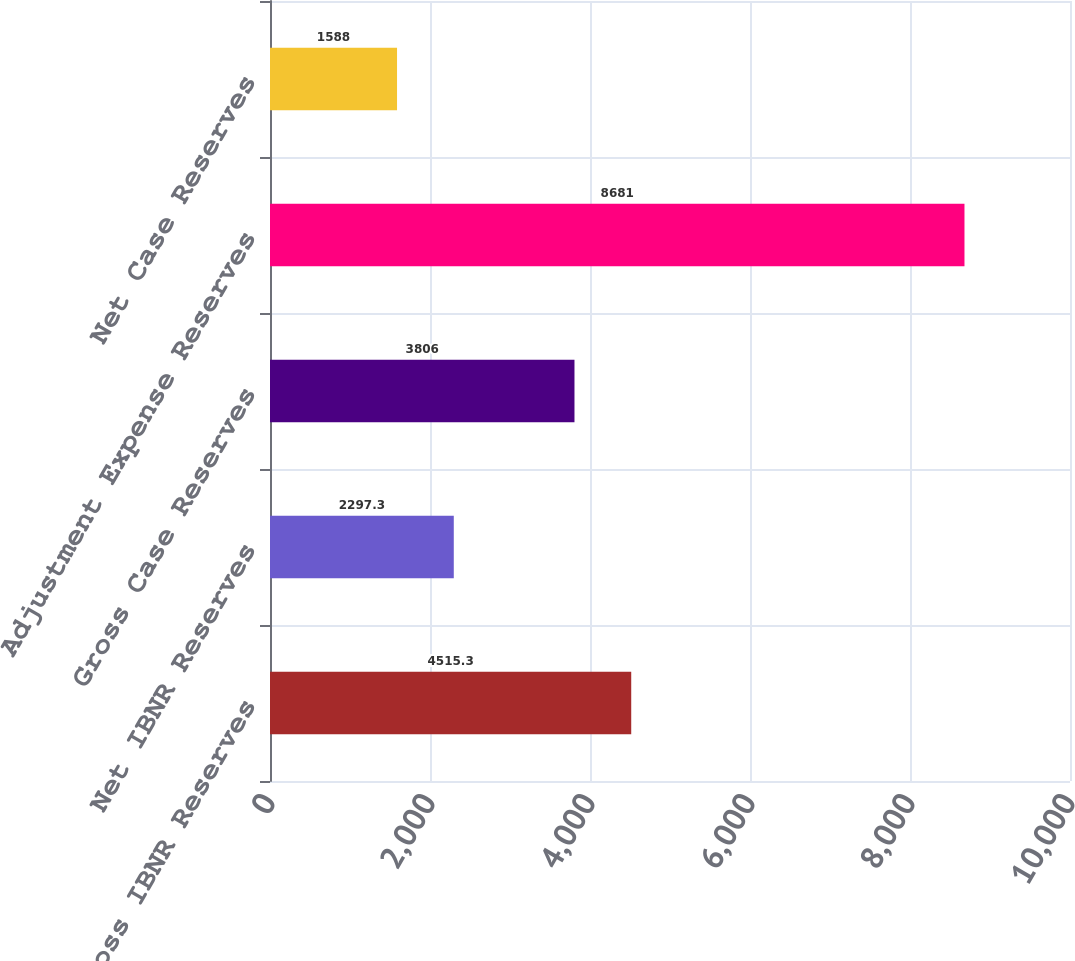Convert chart. <chart><loc_0><loc_0><loc_500><loc_500><bar_chart><fcel>Gross IBNR Reserves<fcel>Net IBNR Reserves<fcel>Gross Case Reserves<fcel>Adjustment Expense Reserves<fcel>Net Case Reserves<nl><fcel>4515.3<fcel>2297.3<fcel>3806<fcel>8681<fcel>1588<nl></chart> 